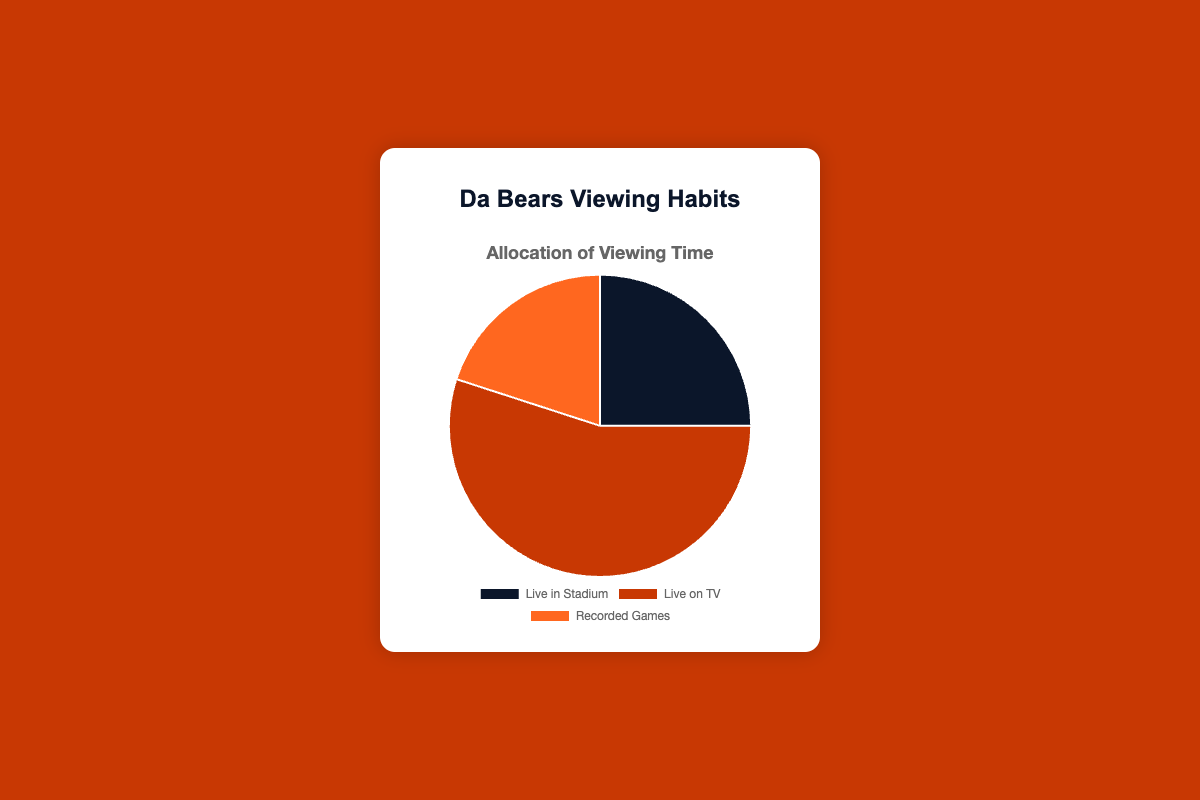Which type of viewing time has the highest allocation? The figure shows three types of viewing time segments. The one with the largest portion visually represents the highest allocation. "Live on TV" segment occupies the largest portion of the pie chart.
Answer: Live on TV What percentage of viewing time is allocated for watching recorded games? The segment labeled "Recorded Games" represents the portion of viewing time allocated for recorded games. This segment is clearly marked as 20% in the visual.
Answer: 20% How much more time is spent watching games live on TV compared to live in the stadium? Look at the percentages for "Live on TV" and "Live in Stadium". Subtract the smaller percentage from the larger one: 55% - 25%.
Answer: 30% What is the total percentage of time spent watching games either live in the stadium or recorded? Sum the percentages for "Live in Stadium" and "Recorded Games" segments: 25% + 20%.
Answer: 45% Which viewing type is represented by the color orange? Identify the color mappings on the chart. The "Recorded Games" segment is represented by the color orange.
Answer: Recorded Games Is the time spent watching games live on TV greater than the combined time spent watching live in the stadium and recorded games? Compare the percentage for "Live on TV" with the sum of "Live in Stadium" and "Recorded Games": 55% vs 45%.
Answer: Yes What percentage of viewing time is not spent watching games live on TV? Subtract the percentage of "Live on TV" from 100%: 100% - 55%.
Answer: 45% Which type of viewing time has the smallest allocation? The segment with the smallest portion visually indicates the smallest allocation. "Recorded Games" segment is the smallest with 20%.
Answer: Recorded Games How much more is the allocation for watching live on TV than recorded games? Subtract the percentage for "Recorded Games" from "Live on TV": 55% - 20%.
Answer: 35% By how many percentage points does the percentage for watching live in the stadium exceed recorded games? Subtract the percentage for "Recorded Games" from "Live in Stadium": 25% - 20%.
Answer: 5% 